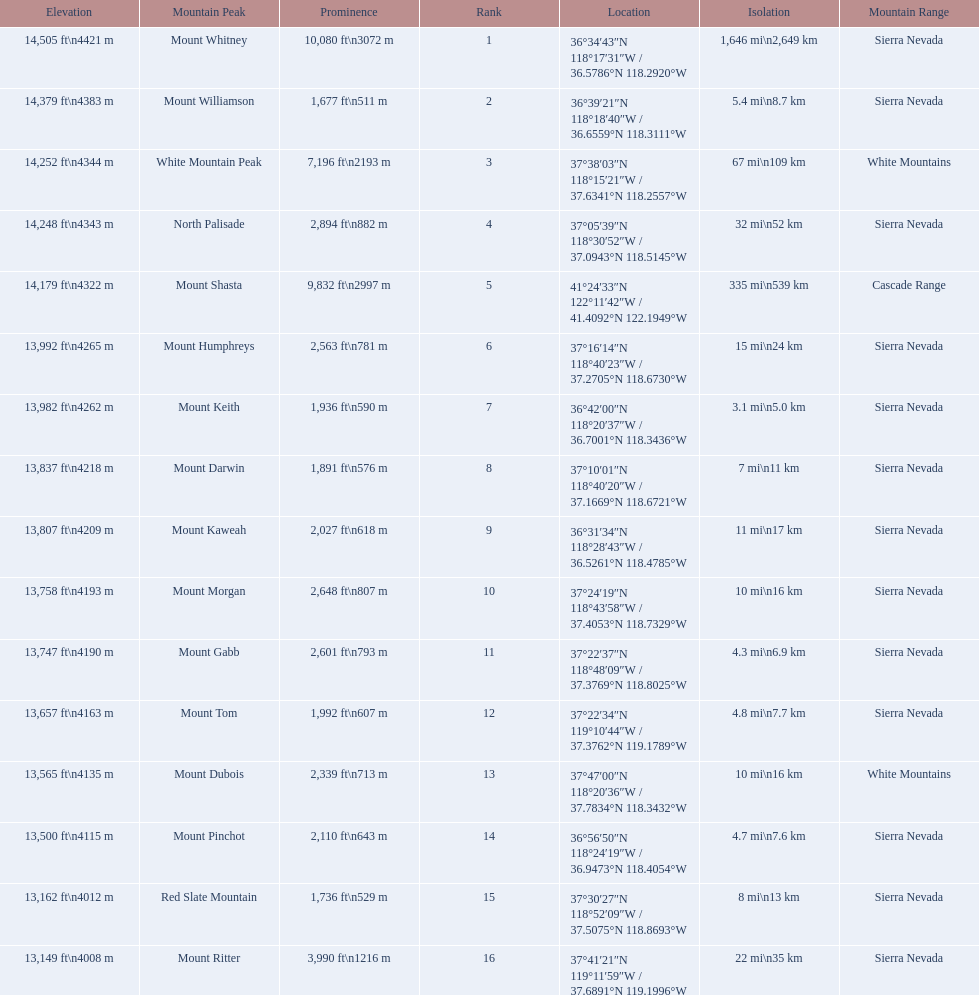Is the peak of mount keith above or below the peak of north palisade? Below. 